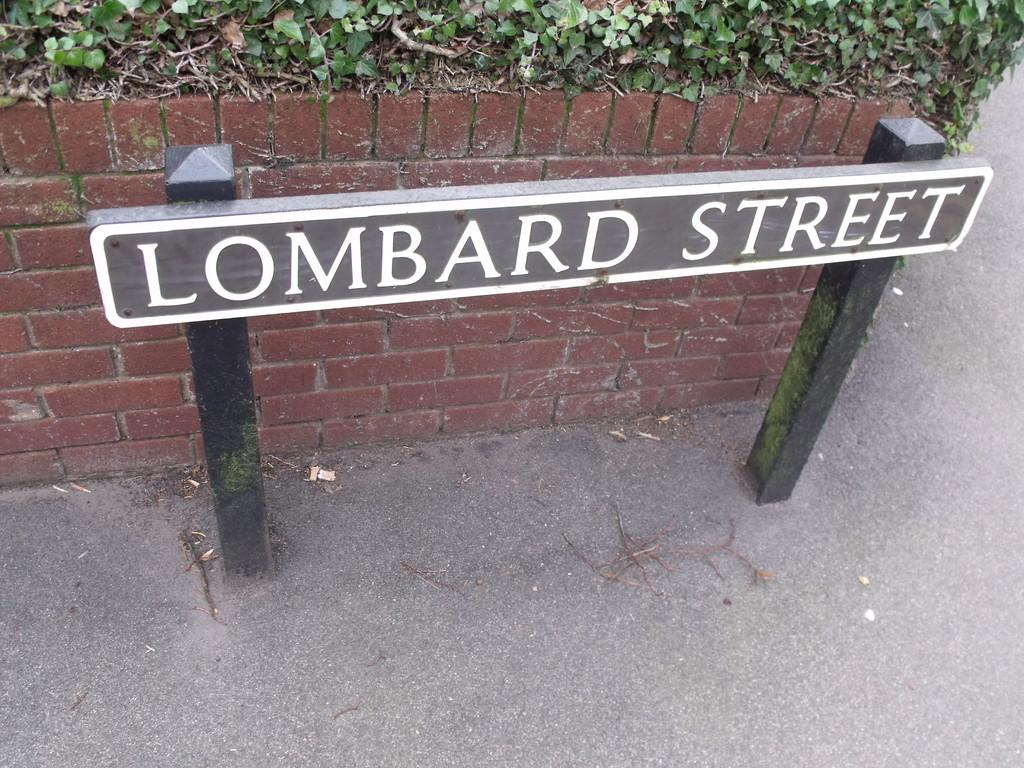What is the main object in the image with text on it? There is a board with text in the image. How is the board supported or held up? The board is attached to two rods. What is the background of the board in the image? There is a brick wall behind the board. Are there any additional elements on the brick wall? Yes, there are plants on the brick wall. What type of beef is being advertised on the board in the image? There is no beef mentioned or advertised on the board in the image. 